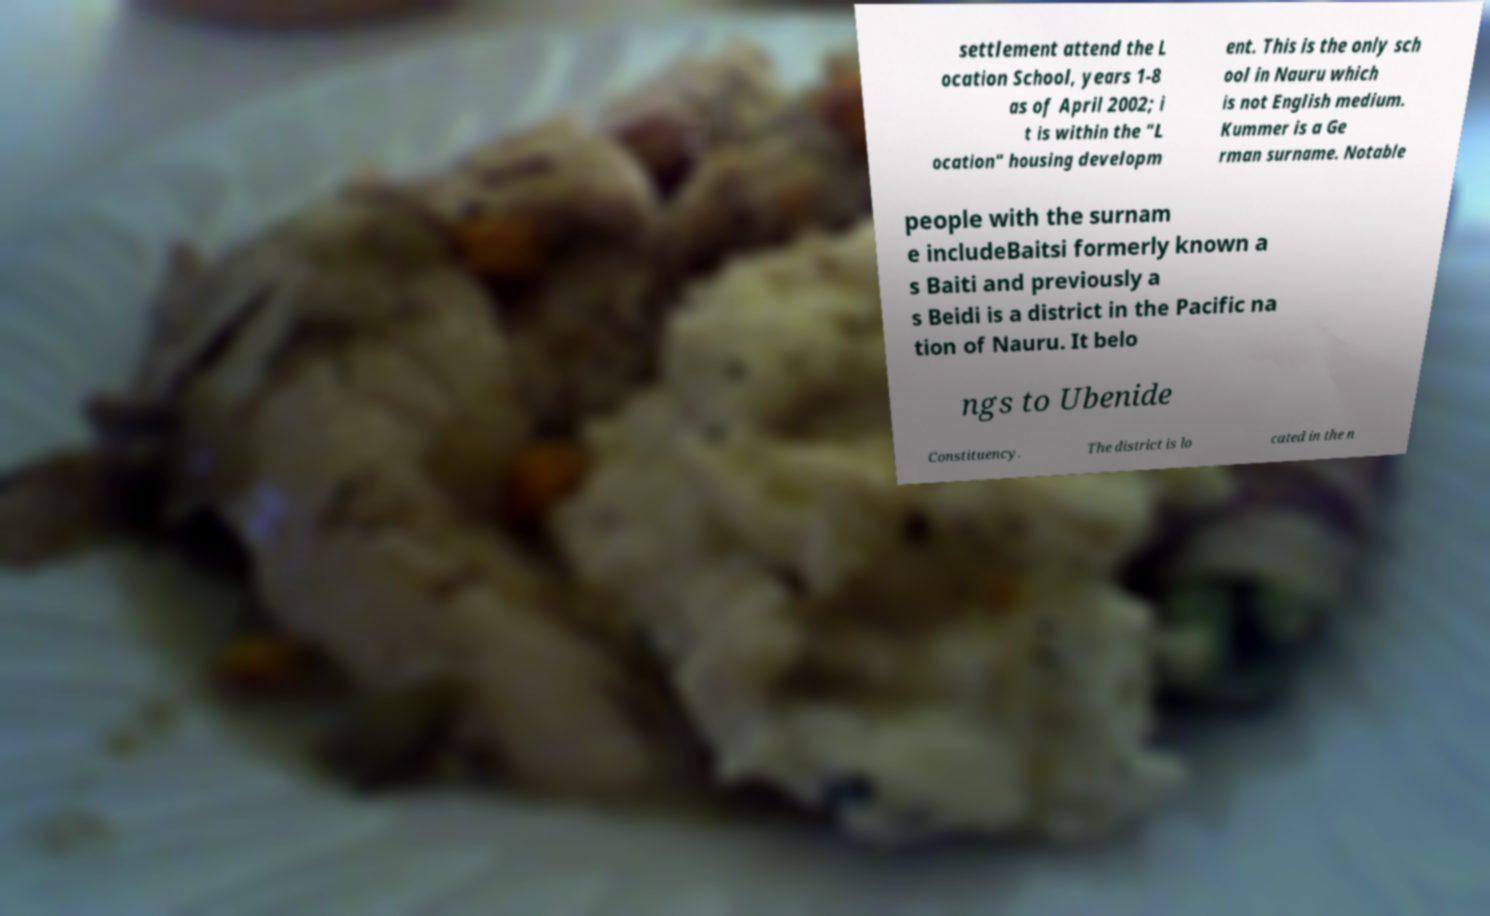Could you extract and type out the text from this image? settlement attend the L ocation School, years 1-8 as of April 2002; i t is within the "L ocation" housing developm ent. This is the only sch ool in Nauru which is not English medium. Kummer is a Ge rman surname. Notable people with the surnam e includeBaitsi formerly known a s Baiti and previously a s Beidi is a district in the Pacific na tion of Nauru. It belo ngs to Ubenide Constituency. The district is lo cated in the n 